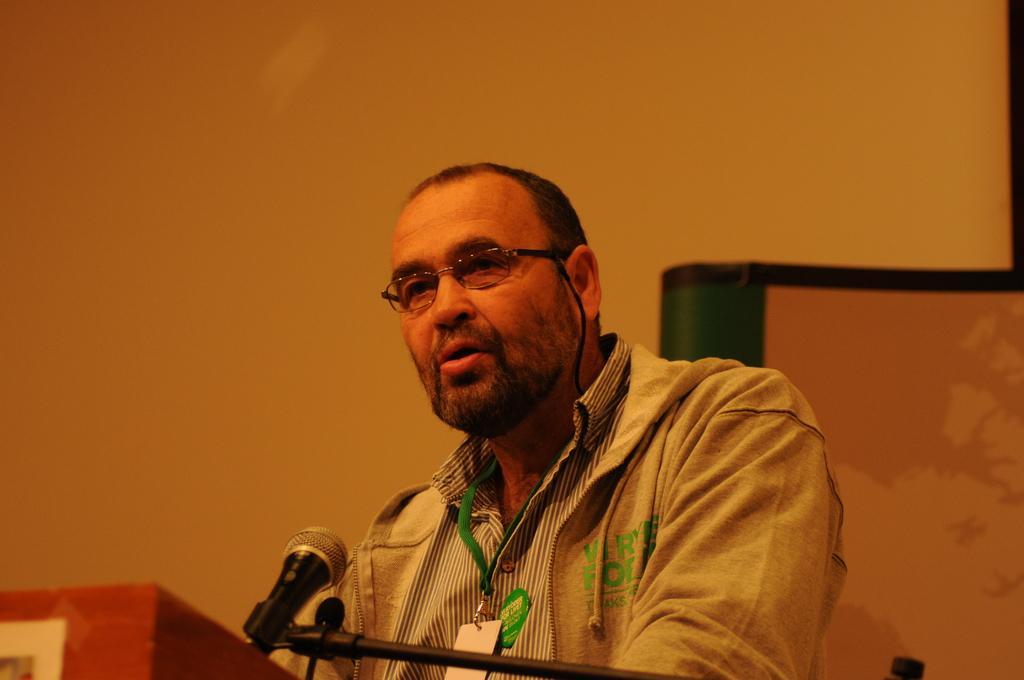How would you summarize this image in a sentence or two? This image is taken indoors. In the background there is a wall with a projector screen on it. In the middle of the image there is a man standing on the floor and talking on a mic. On the left side of the image there is a podium. 